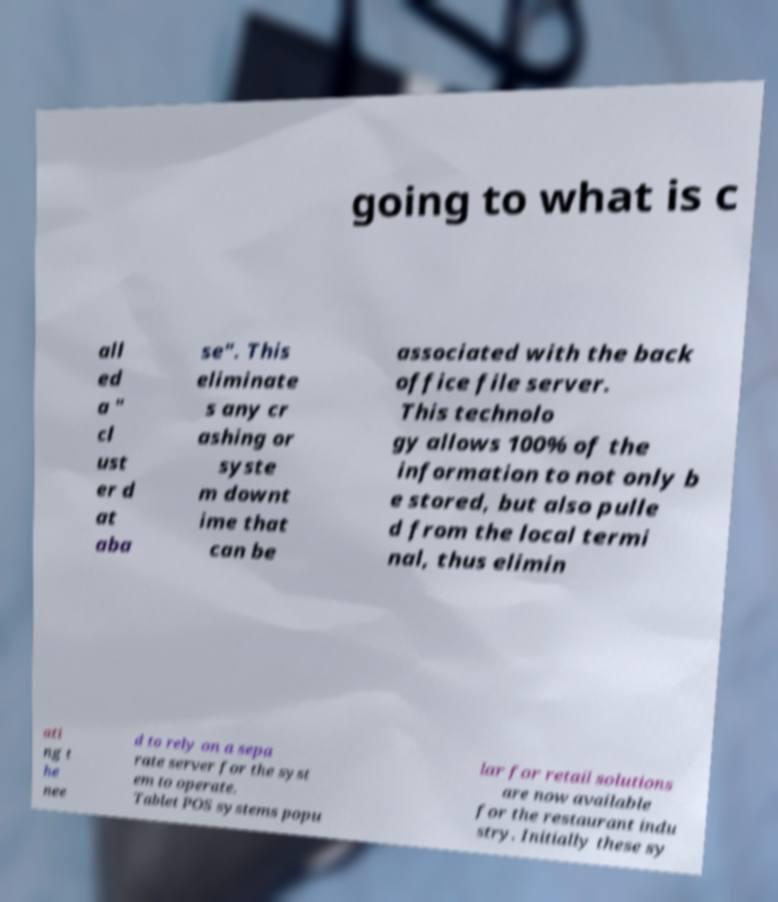Could you assist in decoding the text presented in this image and type it out clearly? going to what is c all ed a " cl ust er d at aba se". This eliminate s any cr ashing or syste m downt ime that can be associated with the back office file server. This technolo gy allows 100% of the information to not only b e stored, but also pulle d from the local termi nal, thus elimin ati ng t he nee d to rely on a sepa rate server for the syst em to operate. Tablet POS systems popu lar for retail solutions are now available for the restaurant indu stry. Initially these sy 